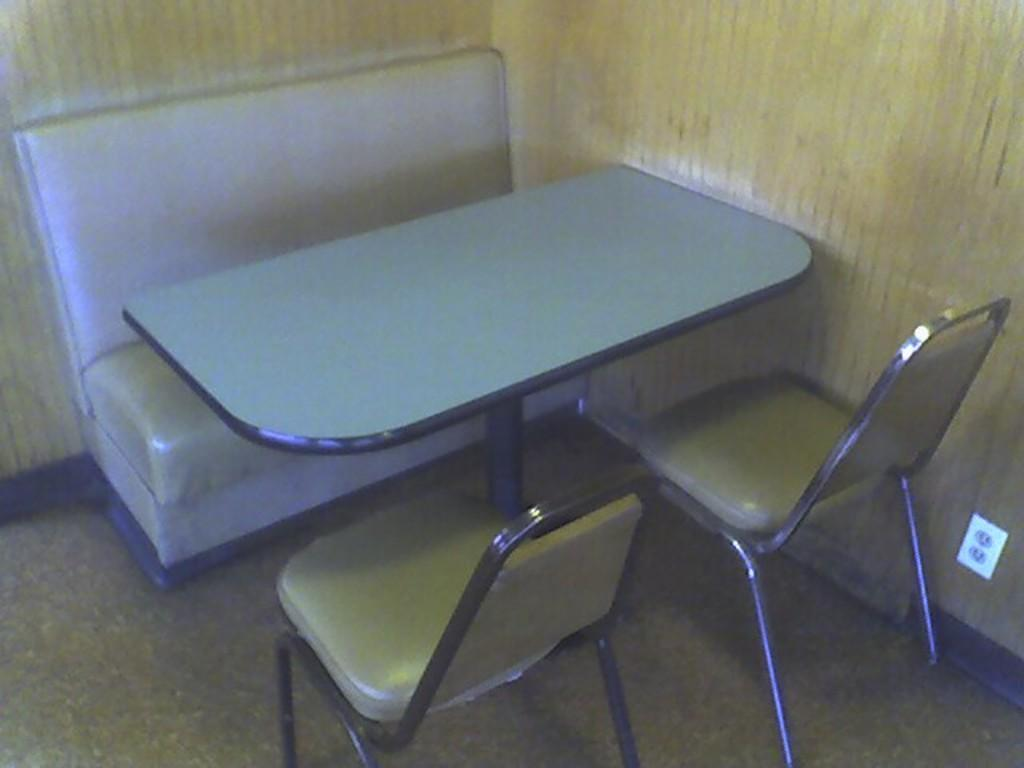What type of furniture is present in the image? There is a table, a couch, and two chairs in the image. Where are these furniture items located? The table, couch, and chairs are placed on the floor. What can be seen in the background of the image? There is a wall visible in the background of the image. What type of territory is being claimed by the chairs in the image? There is no territory being claimed by the chairs in the image; they are simply placed on the floor. 